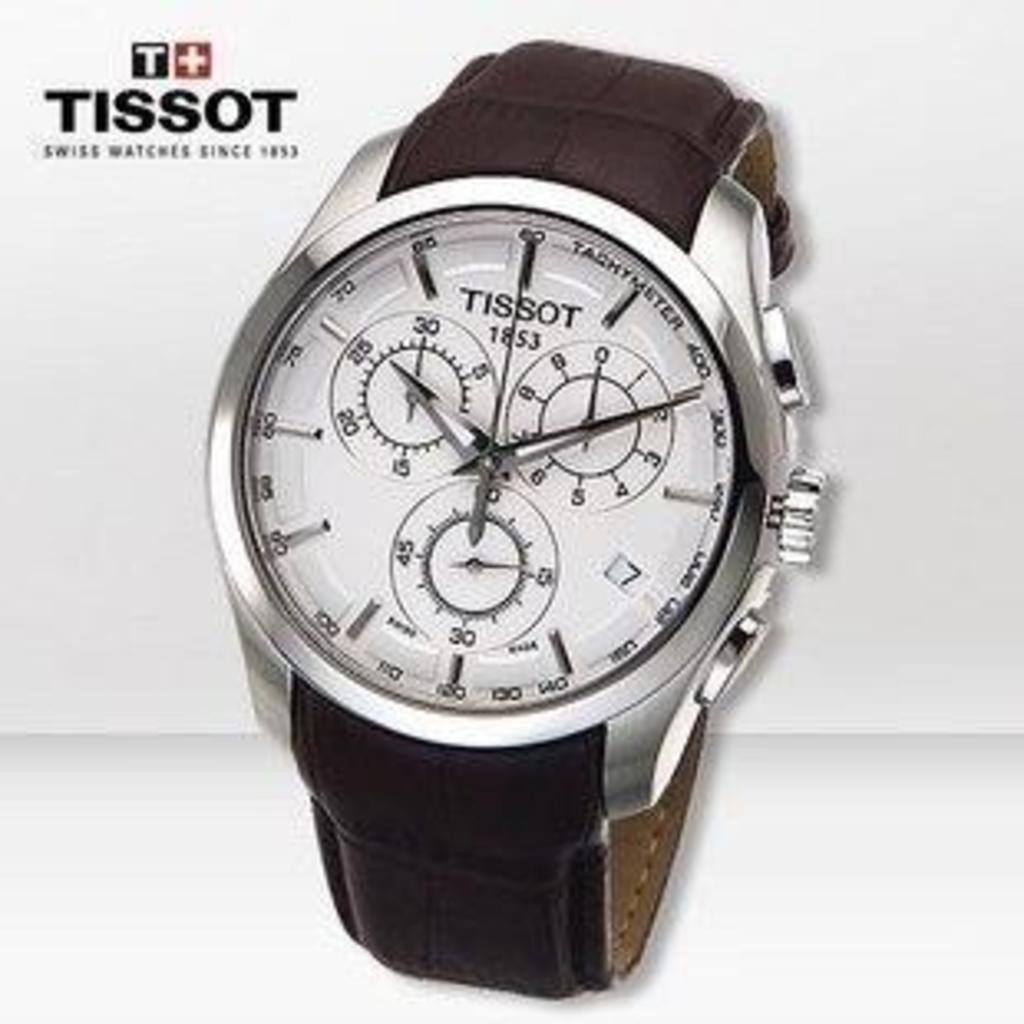What watch brand is advertised?
Your answer should be very brief. Tissot. What number is under the brand name of the watch?
Ensure brevity in your answer.  1853. 